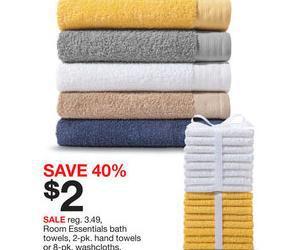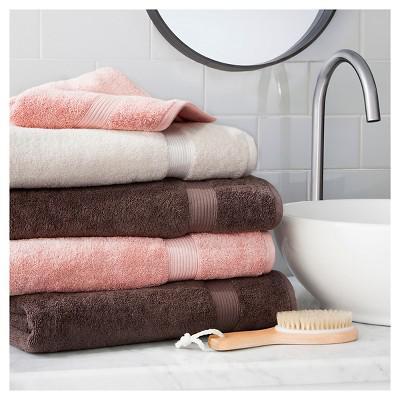The first image is the image on the left, the second image is the image on the right. Assess this claim about the two images: "There are ten towels.". Correct or not? Answer yes or no. No. The first image is the image on the left, the second image is the image on the right. For the images shown, is this caption "There are more towels in the right image than in the left image." true? Answer yes or no. No. 